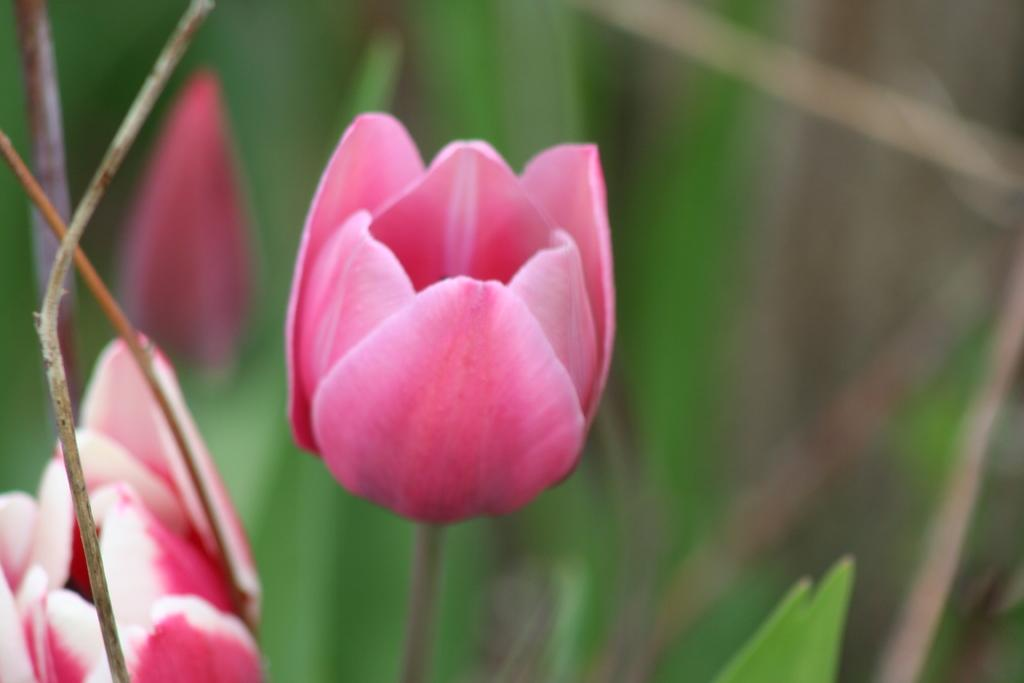Where was the image taken? The image is taken outdoors. What can be seen in the background of the image? There are plants in the background of the image. What is the main subject of the image? There are tulips in the middle of the image. What color are the tulips? The tulips are pink in color. How many ducks are swimming in the pond near the tulips in the image? There is no pond or ducks present in the image; it features tulips and plants in an outdoor setting. 